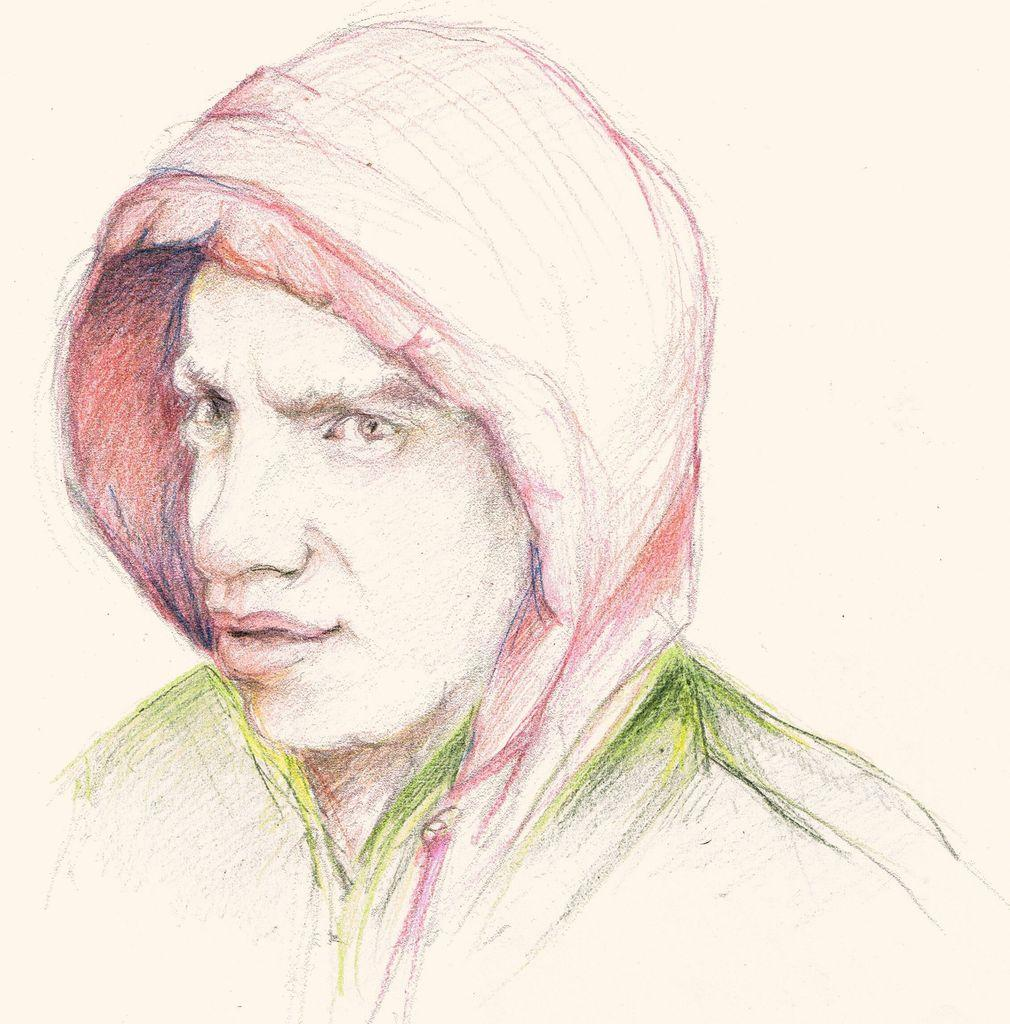What is present on the paper in the image? The image contains a paper with a sketch of a man on it. Can you describe the sketch on the paper? The sketch on the paper is of a man. What type of spark can be seen coming from the man's hand in the image? There is no spark present in the image; it features a sketch of a man on a paper. What type of wool is being used by the queen in the image? There is no queen or wool present in the image; it only features a sketch of a man on a paper. 